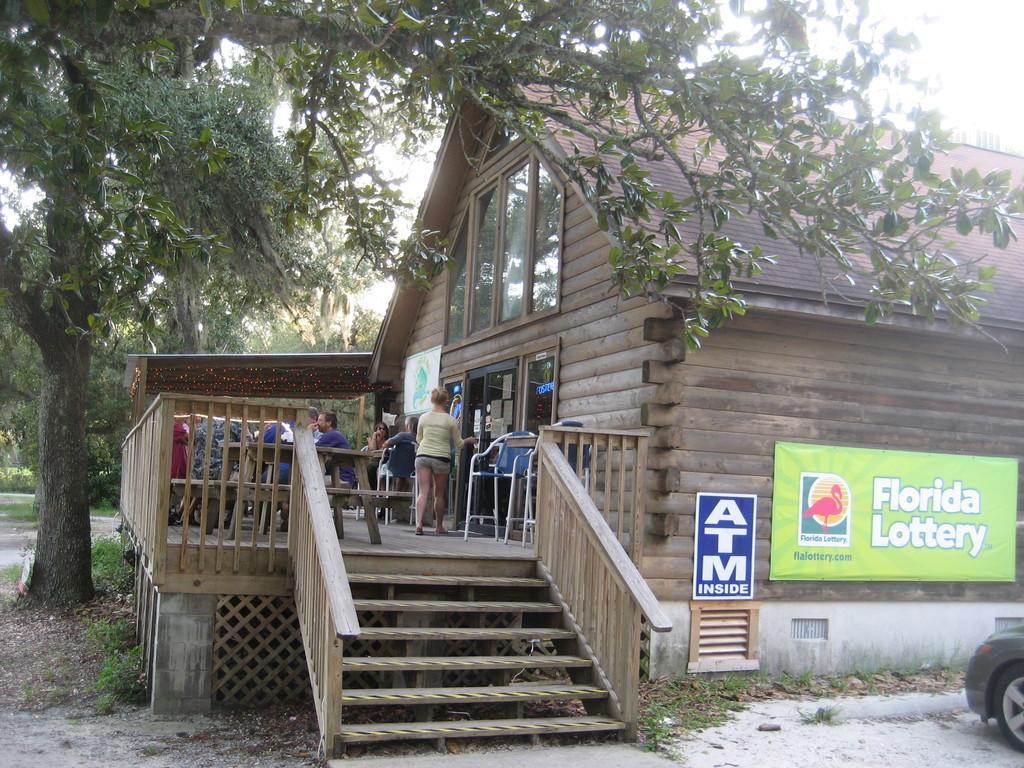Please provide a concise description of this image. There is a building with wooden walls and glass windows and steps with railings. On the building there are benches. Also few people are sitting. Also there are posters with something written on that. Near to the building there is a tree. On the ground there is grass. In the background there are trees and sky. 